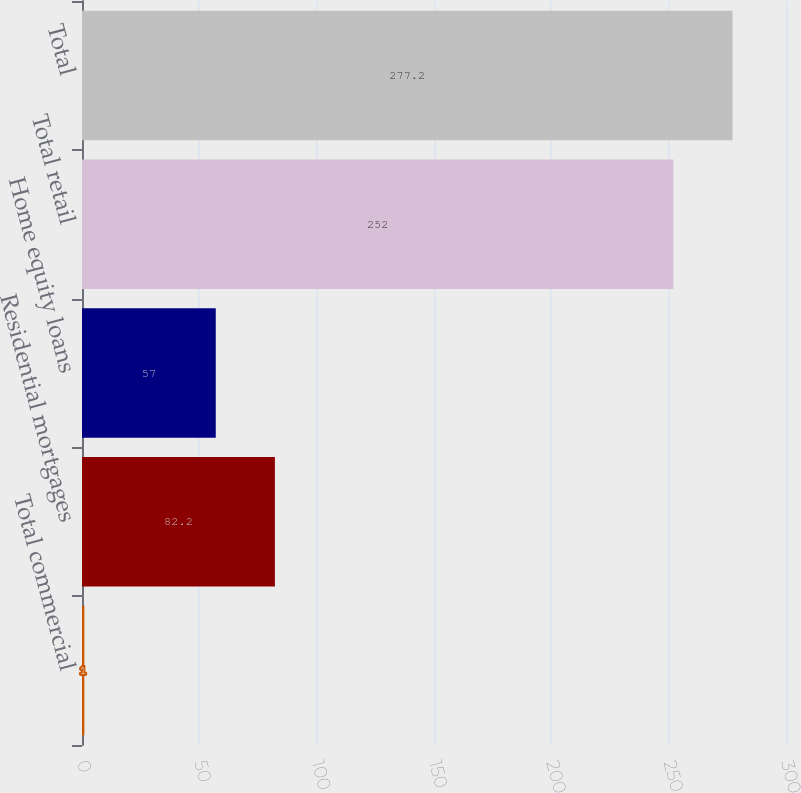Convert chart. <chart><loc_0><loc_0><loc_500><loc_500><bar_chart><fcel>Total commercial<fcel>Residential mortgages<fcel>Home equity loans<fcel>Total retail<fcel>Total<nl><fcel>1<fcel>82.2<fcel>57<fcel>252<fcel>277.2<nl></chart> 